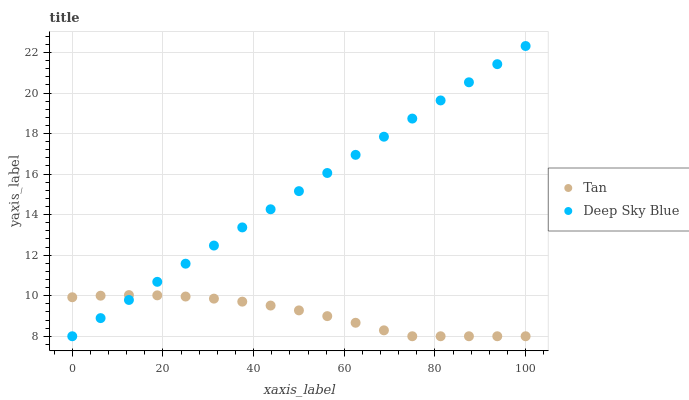Does Tan have the minimum area under the curve?
Answer yes or no. Yes. Does Deep Sky Blue have the maximum area under the curve?
Answer yes or no. Yes. Does Deep Sky Blue have the minimum area under the curve?
Answer yes or no. No. Is Deep Sky Blue the smoothest?
Answer yes or no. Yes. Is Tan the roughest?
Answer yes or no. Yes. Is Deep Sky Blue the roughest?
Answer yes or no. No. Does Tan have the lowest value?
Answer yes or no. Yes. Does Deep Sky Blue have the highest value?
Answer yes or no. Yes. Does Deep Sky Blue intersect Tan?
Answer yes or no. Yes. Is Deep Sky Blue less than Tan?
Answer yes or no. No. Is Deep Sky Blue greater than Tan?
Answer yes or no. No. 